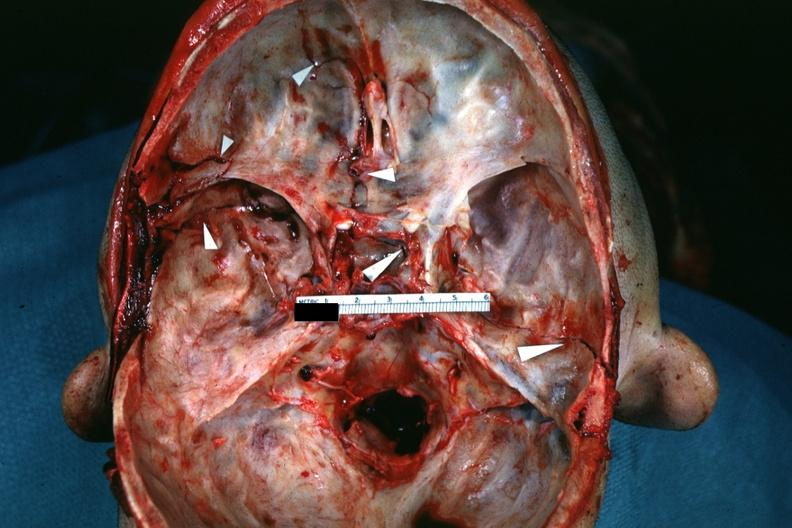what is fractures brain which is slide and close-up view of these fractures?
Answer the question using a single word or phrase. Fractures 